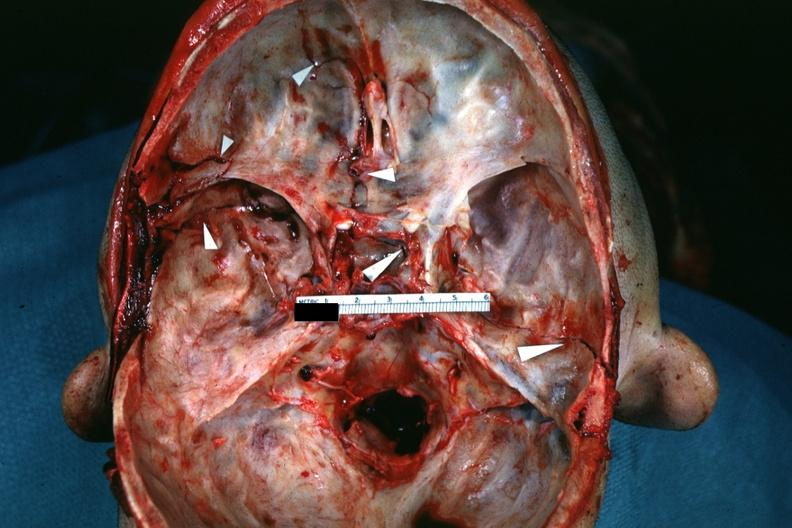what is fractures brain which is slide and close-up view of these fractures?
Answer the question using a single word or phrase. Fractures 